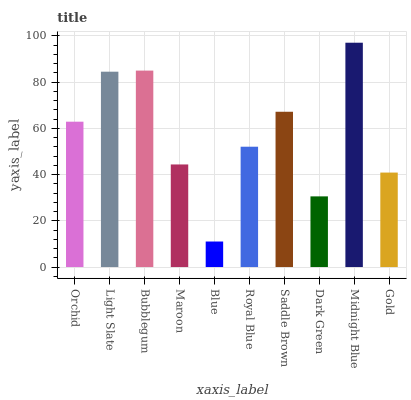Is Blue the minimum?
Answer yes or no. Yes. Is Midnight Blue the maximum?
Answer yes or no. Yes. Is Light Slate the minimum?
Answer yes or no. No. Is Light Slate the maximum?
Answer yes or no. No. Is Light Slate greater than Orchid?
Answer yes or no. Yes. Is Orchid less than Light Slate?
Answer yes or no. Yes. Is Orchid greater than Light Slate?
Answer yes or no. No. Is Light Slate less than Orchid?
Answer yes or no. No. Is Orchid the high median?
Answer yes or no. Yes. Is Royal Blue the low median?
Answer yes or no. Yes. Is Royal Blue the high median?
Answer yes or no. No. Is Saddle Brown the low median?
Answer yes or no. No. 